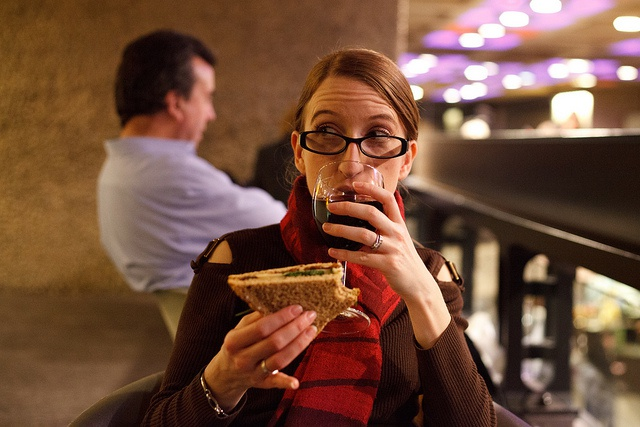Describe the objects in this image and their specific colors. I can see people in maroon, black, and brown tones, people in maroon, black, gray, and darkgray tones, sandwich in maroon, brown, and tan tones, wine glass in maroon, black, and brown tones, and chair in maroon and olive tones in this image. 